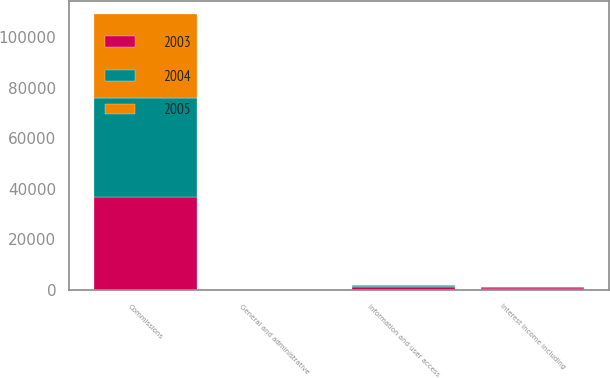Convert chart to OTSL. <chart><loc_0><loc_0><loc_500><loc_500><stacked_bar_chart><ecel><fcel>Commissions<fcel>Information and user access<fcel>Interest income including<fcel>General and administrative<nl><fcel>2003<fcel>36588<fcel>1052<fcel>796<fcel>59<nl><fcel>2004<fcel>39307<fcel>461<fcel>380<fcel>25<nl><fcel>2005<fcel>33023<fcel>203<fcel>65<fcel>12<nl></chart> 